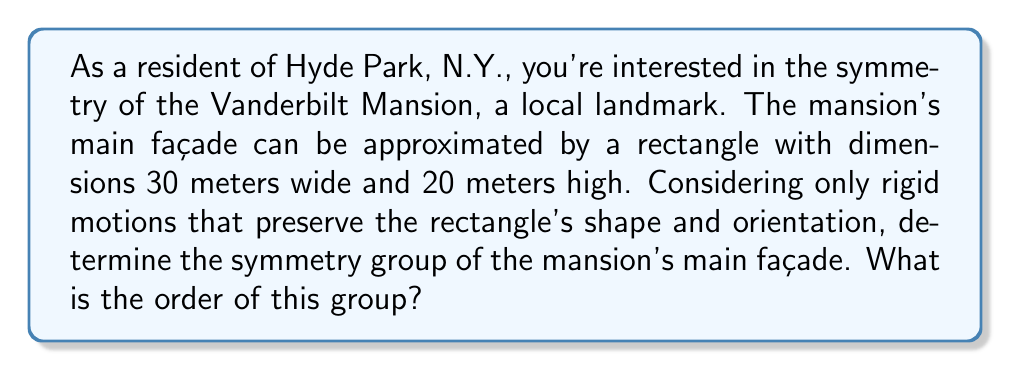Solve this math problem. To determine the symmetry group of the Vanderbilt Mansion's main façade, we need to consider all rigid motions that preserve the rectangle's shape and orientation. Let's approach this step-by-step:

1) First, let's identify the possible symmetries of a rectangle:
   - Identity transformation (do nothing)
   - 180° rotation about the center
   - Reflection across the vertical axis
   - Reflection across the horizontal axis

2) These symmetries form a group under composition. Let's denote them as:
   - $e$: identity
   - $r$: 180° rotation
   - $h$: horizontal reflection
   - $v$: vertical reflection

3) We can verify that these form a group:
   - The set is closed under composition
   - The identity element $e$ exists
   - Each element has an inverse
   - Composition is associative

4) This group is isomorphic to the Klein four-group, $V_4$, which has the following properties:
   - It's abelian (all elements commute)
   - Every non-identity element has order 2

5) The group table for this symmetry group would be:

   $$
   \begin{array}{c|cccc}
     & e & r & h & v \\
   \hline
   e & e & r & h & v \\
   r & r & e & v & h \\
   h & h & v & e & r \\
   v & v & h & r & e
   \end{array}
   $$

6) To find the order of the group, we simply count the number of elements, which is 4.

Therefore, the symmetry group of the Vanderbilt Mansion's main façade is isomorphic to $V_4$, the Klein four-group, and its order is 4.
Answer: The symmetry group of the Vanderbilt Mansion's main façade is isomorphic to the Klein four-group, $V_4$, and its order is 4. 